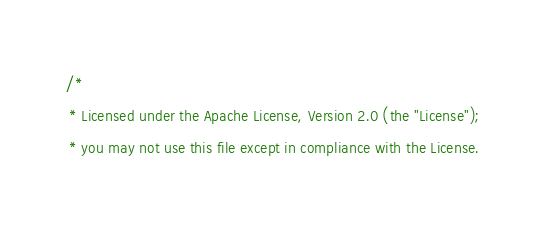Convert code to text. <code><loc_0><loc_0><loc_500><loc_500><_SQL_>/*
 * Licensed under the Apache License, Version 2.0 (the "License");
 * you may not use this file except in compliance with the License.</code> 